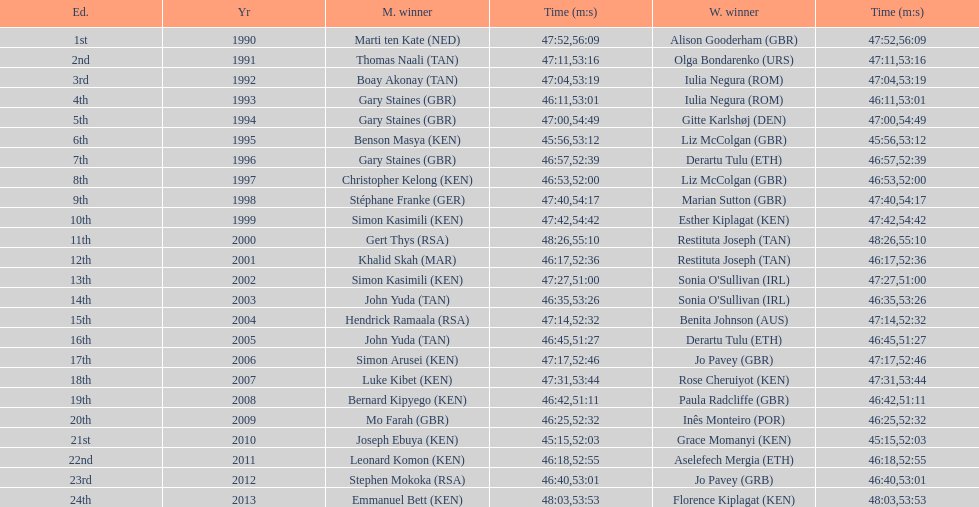Who is the male winner listed before gert thys? Simon Kasimili. 